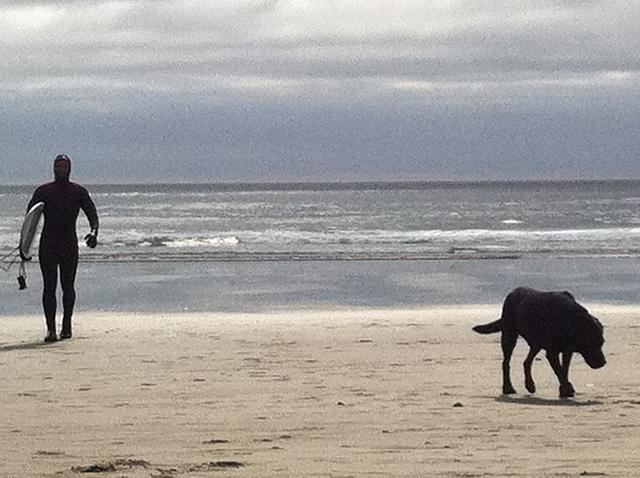Who owns this dog? surfer 